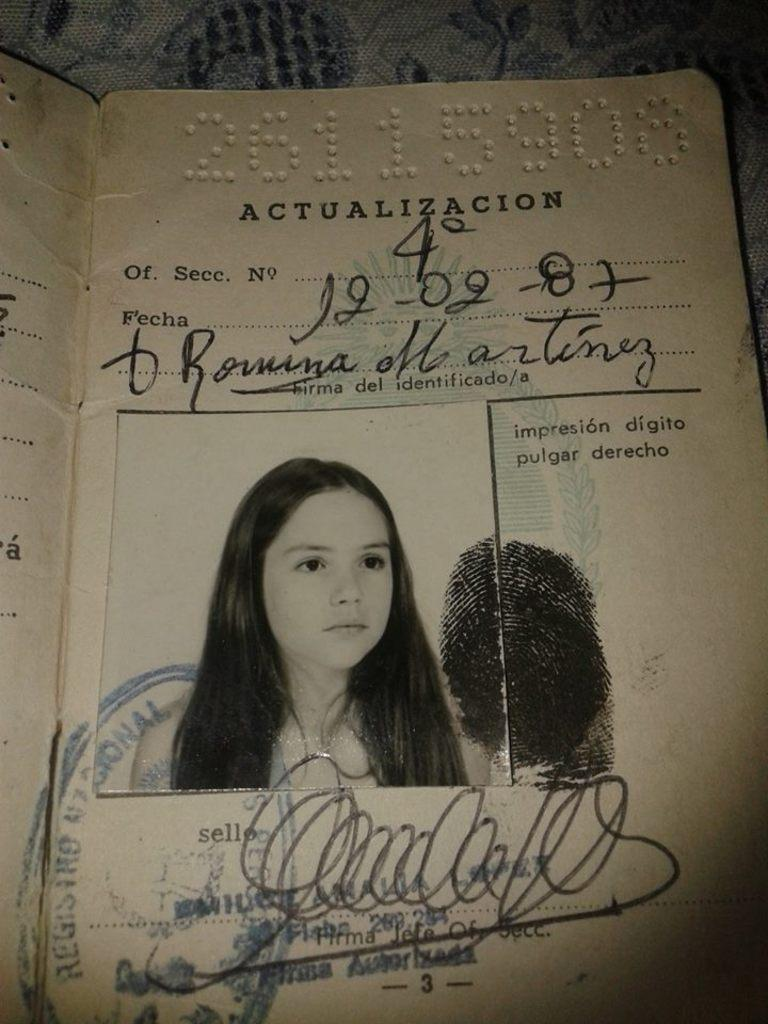What is the main object in the image? There is a card in the image. What is depicted on the card? The card has a photo on it. What is another feature of the card? The card has a thumb impression on it. What else can be found on the card? There is text on the card. How does the fog affect the visibility of the card in the image? There is no fog present in the image, so it does not affect the visibility of the card. 